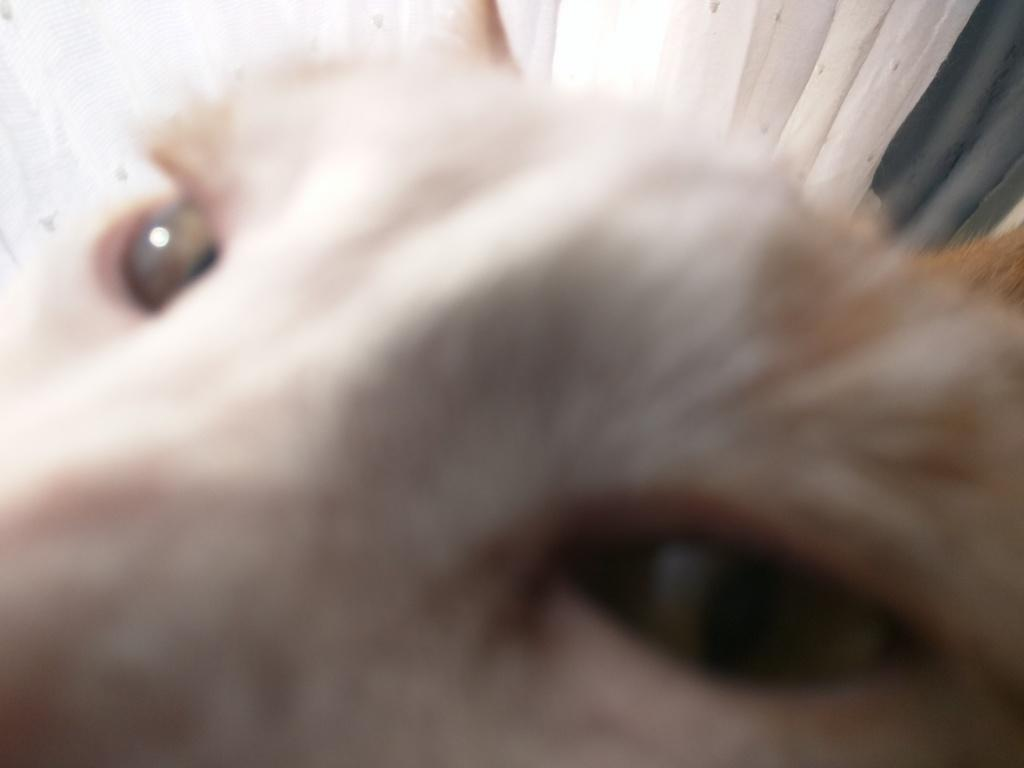What type of living creature is present in the image? There is an animal in the image. What type of jeans is the owl wearing in the image? There is no owl or jeans present in the image. The image only contains an animal, and no clothing is visible. 